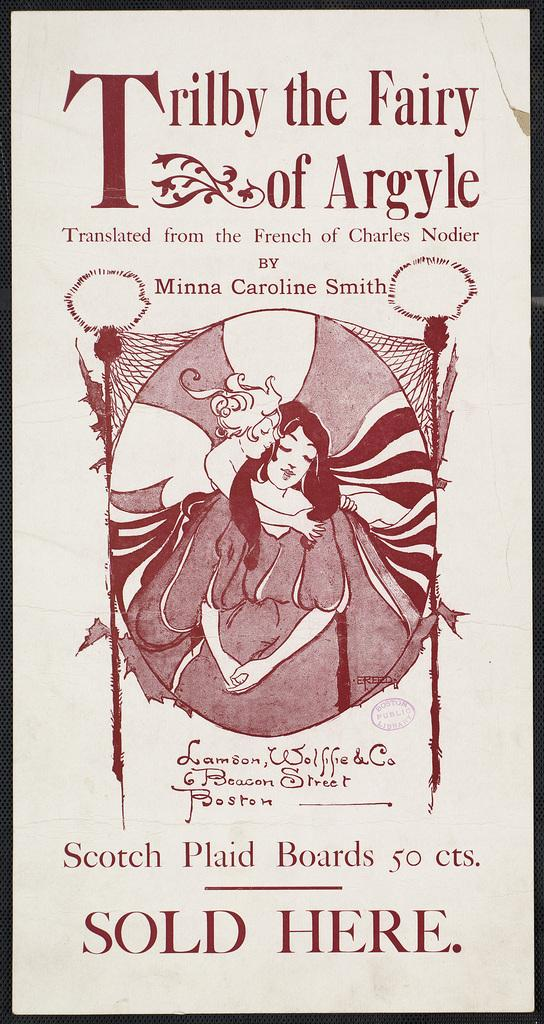<image>
Create a compact narrative representing the image presented. Ad for Scotch plaid boards 50 cts sold here. 